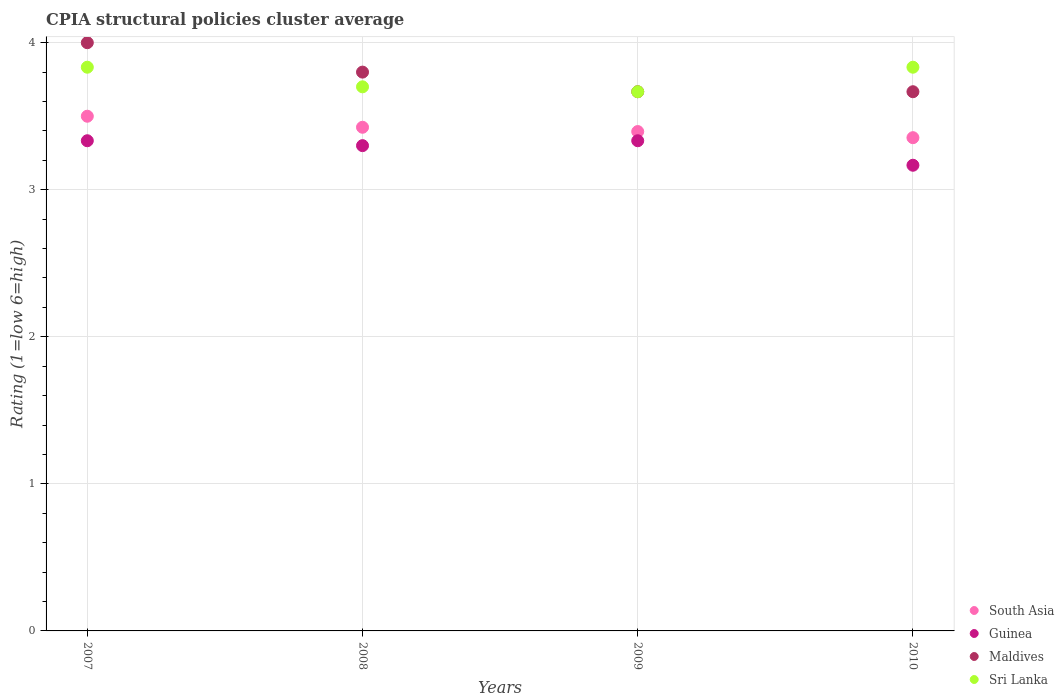How many different coloured dotlines are there?
Offer a terse response. 4. What is the CPIA rating in Sri Lanka in 2009?
Your answer should be very brief. 3.67. Across all years, what is the maximum CPIA rating in Sri Lanka?
Your answer should be very brief. 3.83. Across all years, what is the minimum CPIA rating in South Asia?
Offer a terse response. 3.35. What is the total CPIA rating in Maldives in the graph?
Offer a terse response. 15.13. What is the difference between the CPIA rating in South Asia in 2008 and that in 2009?
Your answer should be compact. 0.03. What is the difference between the CPIA rating in Guinea in 2010 and the CPIA rating in Maldives in 2007?
Give a very brief answer. -0.83. What is the average CPIA rating in South Asia per year?
Keep it short and to the point. 3.42. In the year 2008, what is the difference between the CPIA rating in Guinea and CPIA rating in South Asia?
Your answer should be compact. -0.12. In how many years, is the CPIA rating in Sri Lanka greater than 2.2?
Provide a short and direct response. 4. What is the ratio of the CPIA rating in Sri Lanka in 2007 to that in 2009?
Offer a very short reply. 1.05. Is the CPIA rating in Sri Lanka in 2007 less than that in 2009?
Provide a succinct answer. No. What is the difference between the highest and the second highest CPIA rating in Maldives?
Your answer should be very brief. 0.2. What is the difference between the highest and the lowest CPIA rating in Maldives?
Keep it short and to the point. 0.33. In how many years, is the CPIA rating in Sri Lanka greater than the average CPIA rating in Sri Lanka taken over all years?
Keep it short and to the point. 2. Is it the case that in every year, the sum of the CPIA rating in Sri Lanka and CPIA rating in Guinea  is greater than the CPIA rating in South Asia?
Give a very brief answer. Yes. Does the CPIA rating in Sri Lanka monotonically increase over the years?
Provide a short and direct response. No. Is the CPIA rating in Guinea strictly less than the CPIA rating in Maldives over the years?
Your answer should be compact. Yes. What is the difference between two consecutive major ticks on the Y-axis?
Keep it short and to the point. 1. Are the values on the major ticks of Y-axis written in scientific E-notation?
Give a very brief answer. No. Does the graph contain grids?
Provide a succinct answer. Yes. Where does the legend appear in the graph?
Make the answer very short. Bottom right. How many legend labels are there?
Offer a very short reply. 4. What is the title of the graph?
Provide a short and direct response. CPIA structural policies cluster average. Does "Peru" appear as one of the legend labels in the graph?
Make the answer very short. No. What is the label or title of the Y-axis?
Make the answer very short. Rating (1=low 6=high). What is the Rating (1=low 6=high) in Guinea in 2007?
Make the answer very short. 3.33. What is the Rating (1=low 6=high) of Sri Lanka in 2007?
Keep it short and to the point. 3.83. What is the Rating (1=low 6=high) of South Asia in 2008?
Provide a short and direct response. 3.42. What is the Rating (1=low 6=high) in Maldives in 2008?
Ensure brevity in your answer.  3.8. What is the Rating (1=low 6=high) of Sri Lanka in 2008?
Provide a short and direct response. 3.7. What is the Rating (1=low 6=high) in South Asia in 2009?
Your answer should be very brief. 3.4. What is the Rating (1=low 6=high) in Guinea in 2009?
Offer a terse response. 3.33. What is the Rating (1=low 6=high) in Maldives in 2009?
Give a very brief answer. 3.67. What is the Rating (1=low 6=high) of Sri Lanka in 2009?
Provide a succinct answer. 3.67. What is the Rating (1=low 6=high) in South Asia in 2010?
Your answer should be compact. 3.35. What is the Rating (1=low 6=high) of Guinea in 2010?
Make the answer very short. 3.17. What is the Rating (1=low 6=high) in Maldives in 2010?
Give a very brief answer. 3.67. What is the Rating (1=low 6=high) of Sri Lanka in 2010?
Offer a very short reply. 3.83. Across all years, what is the maximum Rating (1=low 6=high) in Guinea?
Offer a very short reply. 3.33. Across all years, what is the maximum Rating (1=low 6=high) in Maldives?
Make the answer very short. 4. Across all years, what is the maximum Rating (1=low 6=high) of Sri Lanka?
Offer a terse response. 3.83. Across all years, what is the minimum Rating (1=low 6=high) in South Asia?
Your answer should be very brief. 3.35. Across all years, what is the minimum Rating (1=low 6=high) of Guinea?
Provide a succinct answer. 3.17. Across all years, what is the minimum Rating (1=low 6=high) in Maldives?
Give a very brief answer. 3.67. Across all years, what is the minimum Rating (1=low 6=high) in Sri Lanka?
Make the answer very short. 3.67. What is the total Rating (1=low 6=high) of South Asia in the graph?
Ensure brevity in your answer.  13.68. What is the total Rating (1=low 6=high) of Guinea in the graph?
Make the answer very short. 13.13. What is the total Rating (1=low 6=high) of Maldives in the graph?
Provide a short and direct response. 15.13. What is the total Rating (1=low 6=high) of Sri Lanka in the graph?
Provide a short and direct response. 15.03. What is the difference between the Rating (1=low 6=high) of South Asia in 2007 and that in 2008?
Your answer should be very brief. 0.07. What is the difference between the Rating (1=low 6=high) of Sri Lanka in 2007 and that in 2008?
Keep it short and to the point. 0.13. What is the difference between the Rating (1=low 6=high) in South Asia in 2007 and that in 2009?
Your answer should be compact. 0.1. What is the difference between the Rating (1=low 6=high) in Guinea in 2007 and that in 2009?
Offer a very short reply. 0. What is the difference between the Rating (1=low 6=high) in Sri Lanka in 2007 and that in 2009?
Ensure brevity in your answer.  0.17. What is the difference between the Rating (1=low 6=high) of South Asia in 2007 and that in 2010?
Give a very brief answer. 0.15. What is the difference between the Rating (1=low 6=high) of Guinea in 2007 and that in 2010?
Your response must be concise. 0.17. What is the difference between the Rating (1=low 6=high) in Sri Lanka in 2007 and that in 2010?
Make the answer very short. 0. What is the difference between the Rating (1=low 6=high) in South Asia in 2008 and that in 2009?
Your answer should be compact. 0.03. What is the difference between the Rating (1=low 6=high) of Guinea in 2008 and that in 2009?
Keep it short and to the point. -0.03. What is the difference between the Rating (1=low 6=high) of Maldives in 2008 and that in 2009?
Make the answer very short. 0.13. What is the difference between the Rating (1=low 6=high) of Sri Lanka in 2008 and that in 2009?
Provide a succinct answer. 0.03. What is the difference between the Rating (1=low 6=high) of South Asia in 2008 and that in 2010?
Ensure brevity in your answer.  0.07. What is the difference between the Rating (1=low 6=high) of Guinea in 2008 and that in 2010?
Offer a very short reply. 0.13. What is the difference between the Rating (1=low 6=high) of Maldives in 2008 and that in 2010?
Make the answer very short. 0.13. What is the difference between the Rating (1=low 6=high) in Sri Lanka in 2008 and that in 2010?
Provide a short and direct response. -0.13. What is the difference between the Rating (1=low 6=high) in South Asia in 2009 and that in 2010?
Offer a terse response. 0.04. What is the difference between the Rating (1=low 6=high) of Guinea in 2009 and that in 2010?
Your answer should be very brief. 0.17. What is the difference between the Rating (1=low 6=high) of Maldives in 2009 and that in 2010?
Your answer should be very brief. 0. What is the difference between the Rating (1=low 6=high) in South Asia in 2007 and the Rating (1=low 6=high) in Sri Lanka in 2008?
Your answer should be compact. -0.2. What is the difference between the Rating (1=low 6=high) in Guinea in 2007 and the Rating (1=low 6=high) in Maldives in 2008?
Your answer should be very brief. -0.47. What is the difference between the Rating (1=low 6=high) in Guinea in 2007 and the Rating (1=low 6=high) in Sri Lanka in 2008?
Give a very brief answer. -0.37. What is the difference between the Rating (1=low 6=high) of South Asia in 2007 and the Rating (1=low 6=high) of Guinea in 2009?
Offer a terse response. 0.17. What is the difference between the Rating (1=low 6=high) in Guinea in 2007 and the Rating (1=low 6=high) in Sri Lanka in 2009?
Make the answer very short. -0.33. What is the difference between the Rating (1=low 6=high) in Maldives in 2007 and the Rating (1=low 6=high) in Sri Lanka in 2009?
Your response must be concise. 0.33. What is the difference between the Rating (1=low 6=high) in South Asia in 2007 and the Rating (1=low 6=high) in Guinea in 2010?
Provide a short and direct response. 0.33. What is the difference between the Rating (1=low 6=high) of South Asia in 2007 and the Rating (1=low 6=high) of Maldives in 2010?
Give a very brief answer. -0.17. What is the difference between the Rating (1=low 6=high) in Guinea in 2007 and the Rating (1=low 6=high) in Maldives in 2010?
Make the answer very short. -0.33. What is the difference between the Rating (1=low 6=high) of South Asia in 2008 and the Rating (1=low 6=high) of Guinea in 2009?
Offer a terse response. 0.09. What is the difference between the Rating (1=low 6=high) of South Asia in 2008 and the Rating (1=low 6=high) of Maldives in 2009?
Your answer should be very brief. -0.24. What is the difference between the Rating (1=low 6=high) of South Asia in 2008 and the Rating (1=low 6=high) of Sri Lanka in 2009?
Provide a short and direct response. -0.24. What is the difference between the Rating (1=low 6=high) in Guinea in 2008 and the Rating (1=low 6=high) in Maldives in 2009?
Your response must be concise. -0.37. What is the difference between the Rating (1=low 6=high) of Guinea in 2008 and the Rating (1=low 6=high) of Sri Lanka in 2009?
Ensure brevity in your answer.  -0.37. What is the difference between the Rating (1=low 6=high) of Maldives in 2008 and the Rating (1=low 6=high) of Sri Lanka in 2009?
Give a very brief answer. 0.13. What is the difference between the Rating (1=low 6=high) of South Asia in 2008 and the Rating (1=low 6=high) of Guinea in 2010?
Offer a very short reply. 0.26. What is the difference between the Rating (1=low 6=high) of South Asia in 2008 and the Rating (1=low 6=high) of Maldives in 2010?
Make the answer very short. -0.24. What is the difference between the Rating (1=low 6=high) in South Asia in 2008 and the Rating (1=low 6=high) in Sri Lanka in 2010?
Your response must be concise. -0.41. What is the difference between the Rating (1=low 6=high) in Guinea in 2008 and the Rating (1=low 6=high) in Maldives in 2010?
Make the answer very short. -0.37. What is the difference between the Rating (1=low 6=high) of Guinea in 2008 and the Rating (1=low 6=high) of Sri Lanka in 2010?
Keep it short and to the point. -0.53. What is the difference between the Rating (1=low 6=high) of Maldives in 2008 and the Rating (1=low 6=high) of Sri Lanka in 2010?
Provide a succinct answer. -0.03. What is the difference between the Rating (1=low 6=high) of South Asia in 2009 and the Rating (1=low 6=high) of Guinea in 2010?
Ensure brevity in your answer.  0.23. What is the difference between the Rating (1=low 6=high) in South Asia in 2009 and the Rating (1=low 6=high) in Maldives in 2010?
Your answer should be compact. -0.27. What is the difference between the Rating (1=low 6=high) in South Asia in 2009 and the Rating (1=low 6=high) in Sri Lanka in 2010?
Your answer should be compact. -0.44. What is the difference between the Rating (1=low 6=high) in Maldives in 2009 and the Rating (1=low 6=high) in Sri Lanka in 2010?
Your answer should be very brief. -0.17. What is the average Rating (1=low 6=high) of South Asia per year?
Ensure brevity in your answer.  3.42. What is the average Rating (1=low 6=high) of Guinea per year?
Give a very brief answer. 3.28. What is the average Rating (1=low 6=high) of Maldives per year?
Give a very brief answer. 3.78. What is the average Rating (1=low 6=high) in Sri Lanka per year?
Offer a terse response. 3.76. In the year 2007, what is the difference between the Rating (1=low 6=high) in South Asia and Rating (1=low 6=high) in Guinea?
Offer a very short reply. 0.17. In the year 2007, what is the difference between the Rating (1=low 6=high) of South Asia and Rating (1=low 6=high) of Maldives?
Make the answer very short. -0.5. In the year 2008, what is the difference between the Rating (1=low 6=high) of South Asia and Rating (1=low 6=high) of Maldives?
Offer a very short reply. -0.38. In the year 2008, what is the difference between the Rating (1=low 6=high) in South Asia and Rating (1=low 6=high) in Sri Lanka?
Keep it short and to the point. -0.28. In the year 2009, what is the difference between the Rating (1=low 6=high) of South Asia and Rating (1=low 6=high) of Guinea?
Provide a succinct answer. 0.06. In the year 2009, what is the difference between the Rating (1=low 6=high) in South Asia and Rating (1=low 6=high) in Maldives?
Ensure brevity in your answer.  -0.27. In the year 2009, what is the difference between the Rating (1=low 6=high) of South Asia and Rating (1=low 6=high) of Sri Lanka?
Offer a terse response. -0.27. In the year 2009, what is the difference between the Rating (1=low 6=high) of Guinea and Rating (1=low 6=high) of Maldives?
Your answer should be compact. -0.33. In the year 2009, what is the difference between the Rating (1=low 6=high) of Guinea and Rating (1=low 6=high) of Sri Lanka?
Your answer should be compact. -0.33. In the year 2010, what is the difference between the Rating (1=low 6=high) of South Asia and Rating (1=low 6=high) of Guinea?
Offer a terse response. 0.19. In the year 2010, what is the difference between the Rating (1=low 6=high) in South Asia and Rating (1=low 6=high) in Maldives?
Keep it short and to the point. -0.31. In the year 2010, what is the difference between the Rating (1=low 6=high) in South Asia and Rating (1=low 6=high) in Sri Lanka?
Keep it short and to the point. -0.48. In the year 2010, what is the difference between the Rating (1=low 6=high) of Guinea and Rating (1=low 6=high) of Maldives?
Make the answer very short. -0.5. In the year 2010, what is the difference between the Rating (1=low 6=high) in Guinea and Rating (1=low 6=high) in Sri Lanka?
Offer a terse response. -0.67. What is the ratio of the Rating (1=low 6=high) of South Asia in 2007 to that in 2008?
Ensure brevity in your answer.  1.02. What is the ratio of the Rating (1=low 6=high) of Guinea in 2007 to that in 2008?
Your answer should be compact. 1.01. What is the ratio of the Rating (1=low 6=high) of Maldives in 2007 to that in 2008?
Keep it short and to the point. 1.05. What is the ratio of the Rating (1=low 6=high) of Sri Lanka in 2007 to that in 2008?
Provide a short and direct response. 1.04. What is the ratio of the Rating (1=low 6=high) in South Asia in 2007 to that in 2009?
Your answer should be very brief. 1.03. What is the ratio of the Rating (1=low 6=high) in Guinea in 2007 to that in 2009?
Provide a short and direct response. 1. What is the ratio of the Rating (1=low 6=high) in Maldives in 2007 to that in 2009?
Provide a succinct answer. 1.09. What is the ratio of the Rating (1=low 6=high) of Sri Lanka in 2007 to that in 2009?
Your answer should be very brief. 1.05. What is the ratio of the Rating (1=low 6=high) of South Asia in 2007 to that in 2010?
Offer a terse response. 1.04. What is the ratio of the Rating (1=low 6=high) in Guinea in 2007 to that in 2010?
Your answer should be compact. 1.05. What is the ratio of the Rating (1=low 6=high) of Sri Lanka in 2007 to that in 2010?
Give a very brief answer. 1. What is the ratio of the Rating (1=low 6=high) in South Asia in 2008 to that in 2009?
Offer a terse response. 1.01. What is the ratio of the Rating (1=low 6=high) of Guinea in 2008 to that in 2009?
Your answer should be compact. 0.99. What is the ratio of the Rating (1=low 6=high) of Maldives in 2008 to that in 2009?
Offer a terse response. 1.04. What is the ratio of the Rating (1=low 6=high) in Sri Lanka in 2008 to that in 2009?
Keep it short and to the point. 1.01. What is the ratio of the Rating (1=low 6=high) of South Asia in 2008 to that in 2010?
Your answer should be very brief. 1.02. What is the ratio of the Rating (1=low 6=high) in Guinea in 2008 to that in 2010?
Ensure brevity in your answer.  1.04. What is the ratio of the Rating (1=low 6=high) in Maldives in 2008 to that in 2010?
Provide a succinct answer. 1.04. What is the ratio of the Rating (1=low 6=high) of Sri Lanka in 2008 to that in 2010?
Ensure brevity in your answer.  0.97. What is the ratio of the Rating (1=low 6=high) in South Asia in 2009 to that in 2010?
Your answer should be very brief. 1.01. What is the ratio of the Rating (1=low 6=high) in Guinea in 2009 to that in 2010?
Your answer should be very brief. 1.05. What is the ratio of the Rating (1=low 6=high) in Sri Lanka in 2009 to that in 2010?
Provide a short and direct response. 0.96. What is the difference between the highest and the second highest Rating (1=low 6=high) in South Asia?
Keep it short and to the point. 0.07. What is the difference between the highest and the second highest Rating (1=low 6=high) of Sri Lanka?
Your response must be concise. 0. What is the difference between the highest and the lowest Rating (1=low 6=high) of South Asia?
Offer a terse response. 0.15. What is the difference between the highest and the lowest Rating (1=low 6=high) of Maldives?
Give a very brief answer. 0.33. 